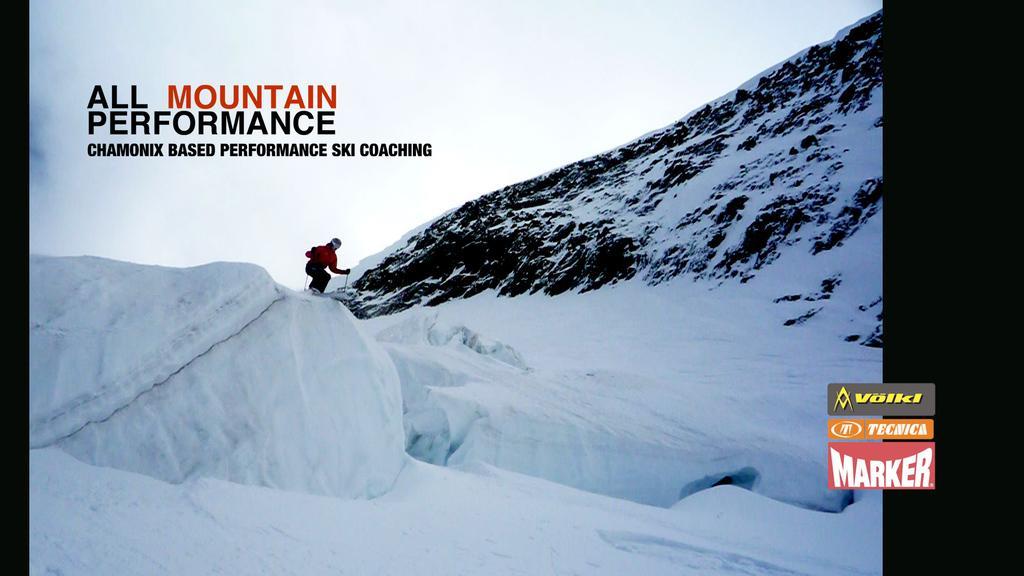How would you summarize this image in a sentence or two? In the center of the image a person is standing and holding an objects and wearing a helmet. On the right side of the image a hill is present. At the top of the image sky is there. At the bottom of the image snow is present. 